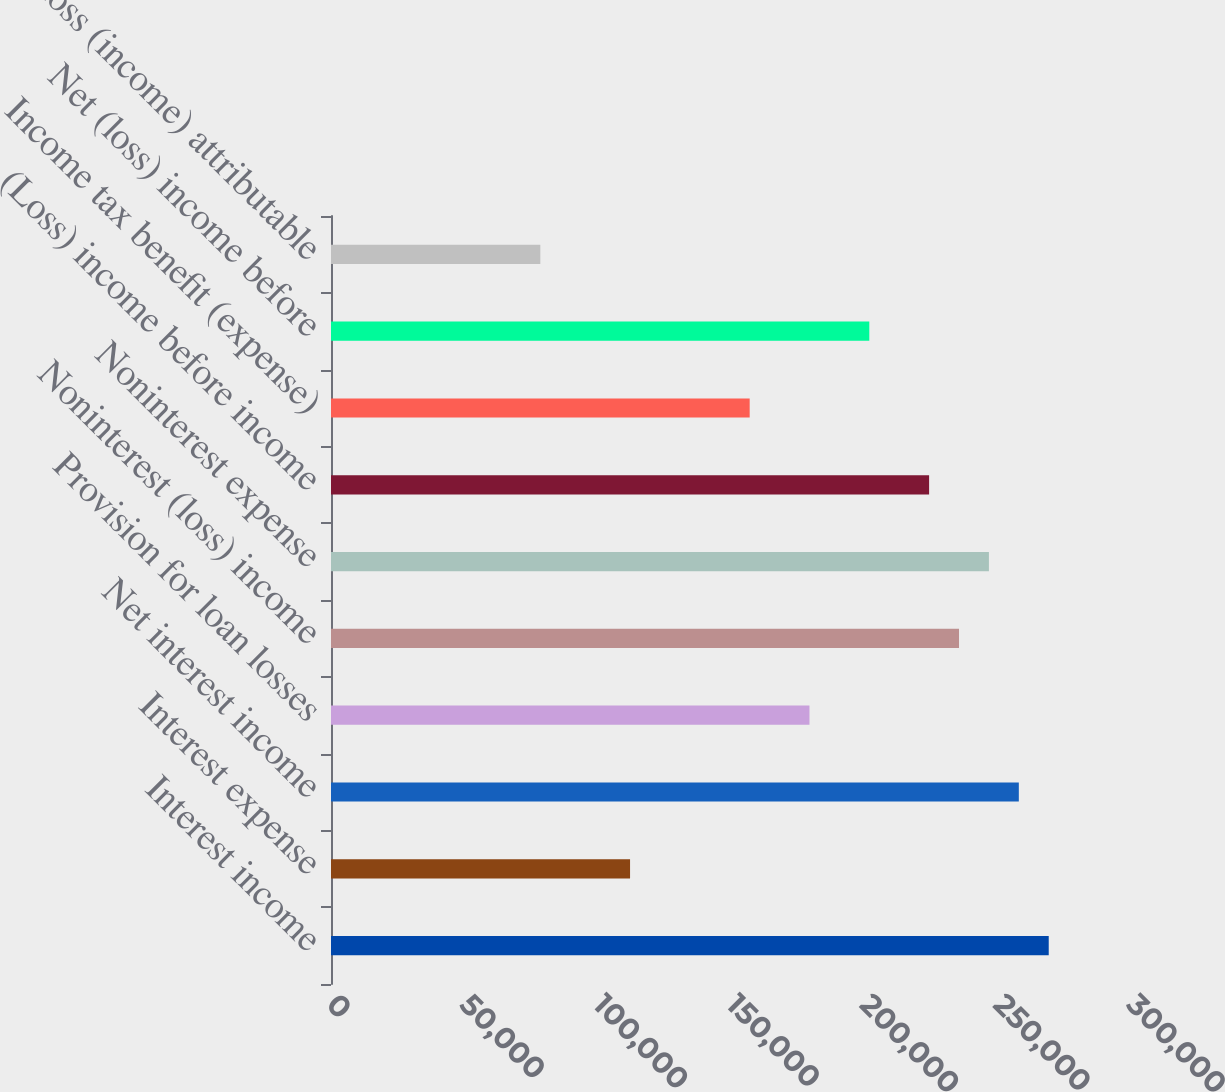Convert chart to OTSL. <chart><loc_0><loc_0><loc_500><loc_500><bar_chart><fcel>Interest income<fcel>Interest expense<fcel>Net interest income<fcel>Provision for loan losses<fcel>Noninterest (loss) income<fcel>Noninterest expense<fcel>(Loss) income before income<fcel>Income tax benefit (expense)<fcel>Net (loss) income before<fcel>Net loss (income) attributable<nl><fcel>269148<fcel>112145<fcel>257934<fcel>179432<fcel>235505<fcel>246719<fcel>224290<fcel>157003<fcel>201861<fcel>78501.5<nl></chart> 